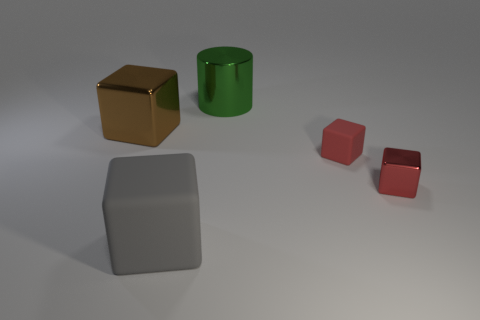There is a cube that is both in front of the tiny rubber block and on the right side of the big rubber object; what is its color?
Your answer should be very brief. Red. How many big things are gray blocks or red shiny blocks?
Your answer should be compact. 1. The gray thing that is the same shape as the brown object is what size?
Your answer should be compact. Large. The big gray matte thing is what shape?
Make the answer very short. Cube. Do the cylinder and the big block behind the tiny metallic block have the same material?
Offer a very short reply. Yes. What number of rubber things are either big cubes or green cylinders?
Make the answer very short. 1. What is the size of the matte object that is in front of the small shiny cube?
Give a very brief answer. Large. What is the size of the green cylinder that is the same material as the large brown thing?
Ensure brevity in your answer.  Large. What number of other matte blocks have the same color as the large rubber block?
Your answer should be very brief. 0. Are there any large yellow matte cubes?
Offer a terse response. No. 